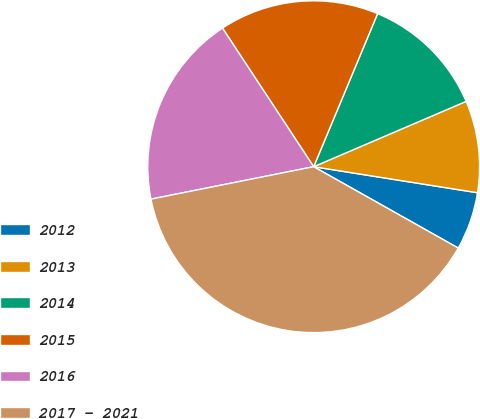Convert chart. <chart><loc_0><loc_0><loc_500><loc_500><pie_chart><fcel>2012<fcel>2013<fcel>2014<fcel>2015<fcel>2016<fcel>2017 - 2021<nl><fcel>5.65%<fcel>8.95%<fcel>12.26%<fcel>15.56%<fcel>18.87%<fcel>38.71%<nl></chart> 